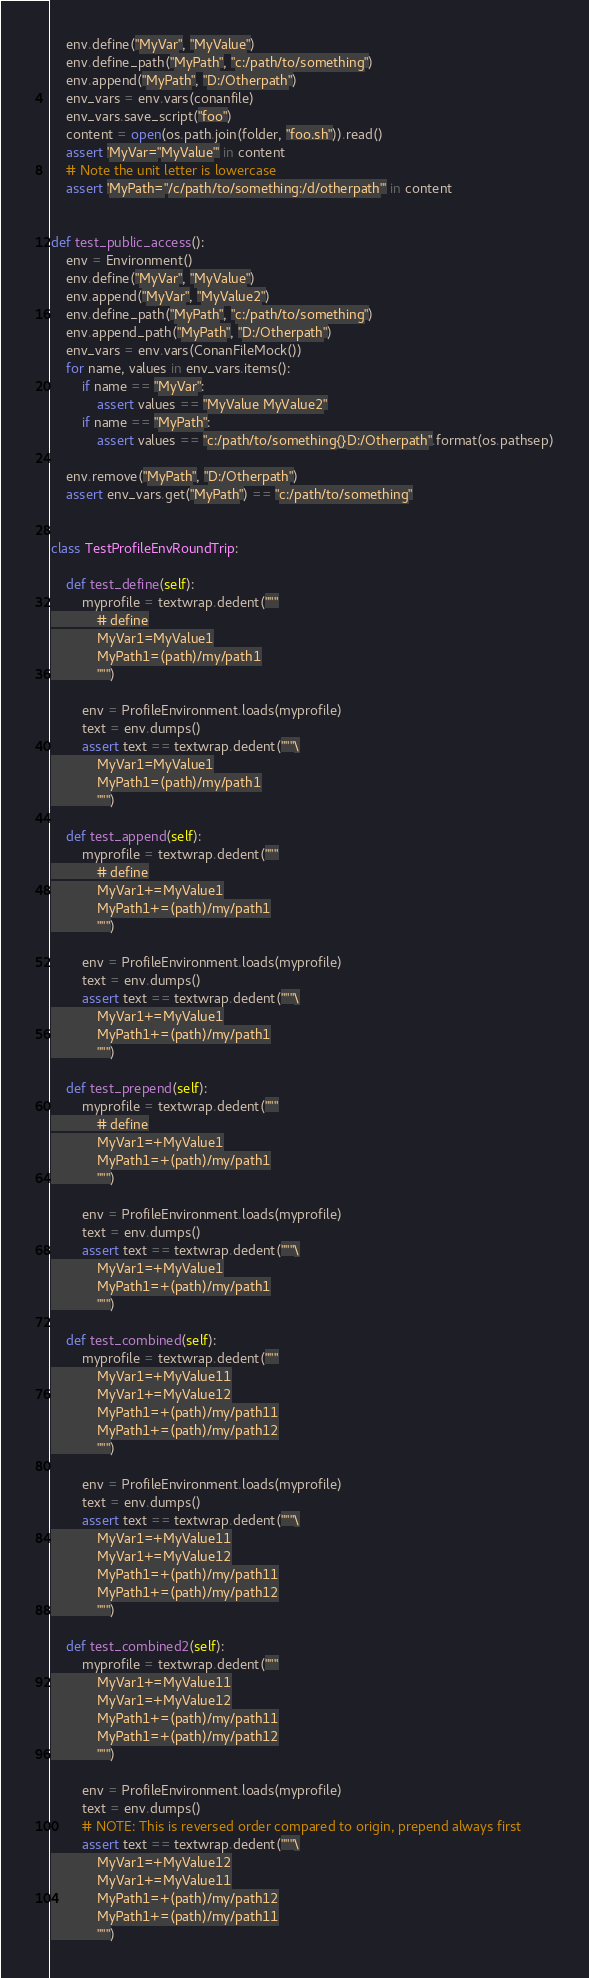Convert code to text. <code><loc_0><loc_0><loc_500><loc_500><_Python_>    env.define("MyVar", "MyValue")
    env.define_path("MyPath", "c:/path/to/something")
    env.append("MyPath", "D:/Otherpath")
    env_vars = env.vars(conanfile)
    env_vars.save_script("foo")
    content = open(os.path.join(folder, "foo.sh")).read()
    assert 'MyVar="MyValue"' in content
    # Note the unit letter is lowercase
    assert 'MyPath="/c/path/to/something:/d/otherpath"' in content


def test_public_access():
    env = Environment()
    env.define("MyVar", "MyValue")
    env.append("MyVar", "MyValue2")
    env.define_path("MyPath", "c:/path/to/something")
    env.append_path("MyPath", "D:/Otherpath")
    env_vars = env.vars(ConanFileMock())
    for name, values in env_vars.items():
        if name == "MyVar":
            assert values == "MyValue MyValue2"
        if name == "MyPath":
            assert values == "c:/path/to/something{}D:/Otherpath".format(os.pathsep)

    env.remove("MyPath", "D:/Otherpath")
    assert env_vars.get("MyPath") == "c:/path/to/something"


class TestProfileEnvRoundTrip:

    def test_define(self):
        myprofile = textwrap.dedent("""
            # define
            MyVar1=MyValue1
            MyPath1=(path)/my/path1
            """)

        env = ProfileEnvironment.loads(myprofile)
        text = env.dumps()
        assert text == textwrap.dedent("""\
            MyVar1=MyValue1
            MyPath1=(path)/my/path1
            """)

    def test_append(self):
        myprofile = textwrap.dedent("""
            # define
            MyVar1+=MyValue1
            MyPath1+=(path)/my/path1
            """)

        env = ProfileEnvironment.loads(myprofile)
        text = env.dumps()
        assert text == textwrap.dedent("""\
            MyVar1+=MyValue1
            MyPath1+=(path)/my/path1
            """)

    def test_prepend(self):
        myprofile = textwrap.dedent("""
            # define
            MyVar1=+MyValue1
            MyPath1=+(path)/my/path1
            """)

        env = ProfileEnvironment.loads(myprofile)
        text = env.dumps()
        assert text == textwrap.dedent("""\
            MyVar1=+MyValue1
            MyPath1=+(path)/my/path1
            """)

    def test_combined(self):
        myprofile = textwrap.dedent("""
            MyVar1=+MyValue11
            MyVar1+=MyValue12
            MyPath1=+(path)/my/path11
            MyPath1+=(path)/my/path12
            """)

        env = ProfileEnvironment.loads(myprofile)
        text = env.dumps()
        assert text == textwrap.dedent("""\
            MyVar1=+MyValue11
            MyVar1+=MyValue12
            MyPath1=+(path)/my/path11
            MyPath1+=(path)/my/path12
            """)

    def test_combined2(self):
        myprofile = textwrap.dedent("""
            MyVar1+=MyValue11
            MyVar1=+MyValue12
            MyPath1+=(path)/my/path11
            MyPath1=+(path)/my/path12
            """)

        env = ProfileEnvironment.loads(myprofile)
        text = env.dumps()
        # NOTE: This is reversed order compared to origin, prepend always first
        assert text == textwrap.dedent("""\
            MyVar1=+MyValue12
            MyVar1+=MyValue11
            MyPath1=+(path)/my/path12
            MyPath1+=(path)/my/path11
            """)
</code> 